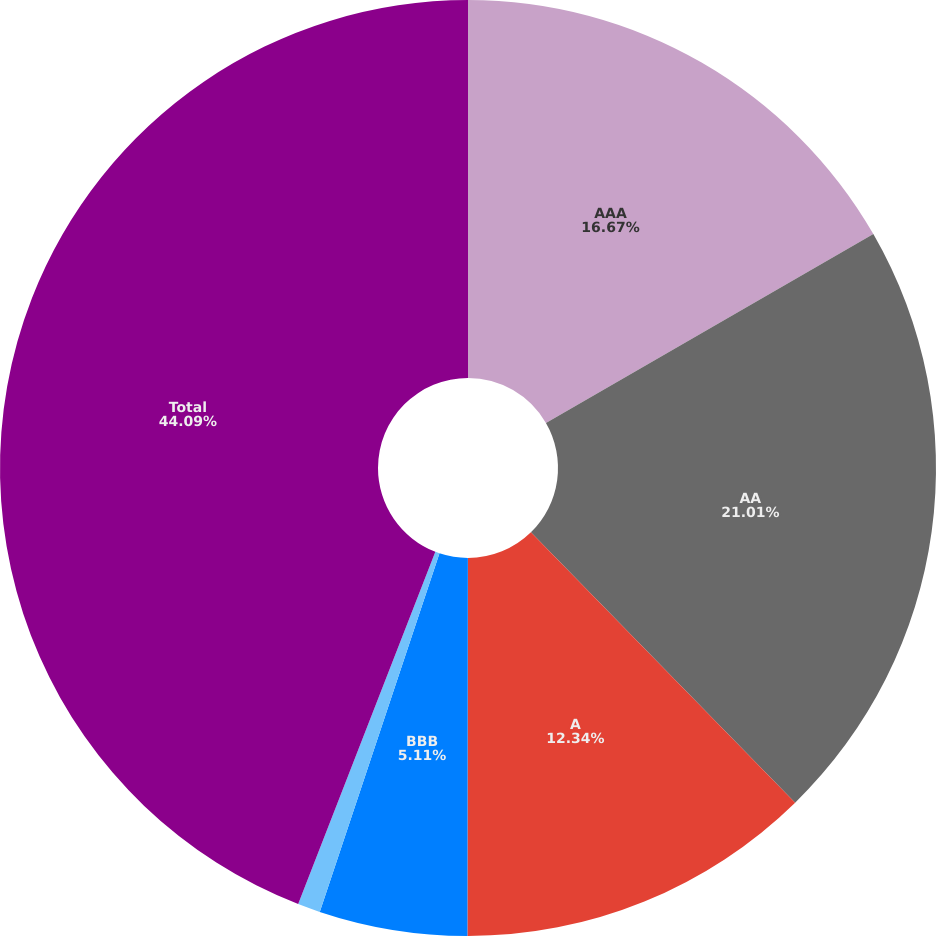<chart> <loc_0><loc_0><loc_500><loc_500><pie_chart><fcel>AAA<fcel>AA<fcel>A<fcel>BBB<fcel>Below investment grade<fcel>Total<nl><fcel>16.67%<fcel>21.01%<fcel>12.34%<fcel>5.11%<fcel>0.78%<fcel>44.09%<nl></chart> 